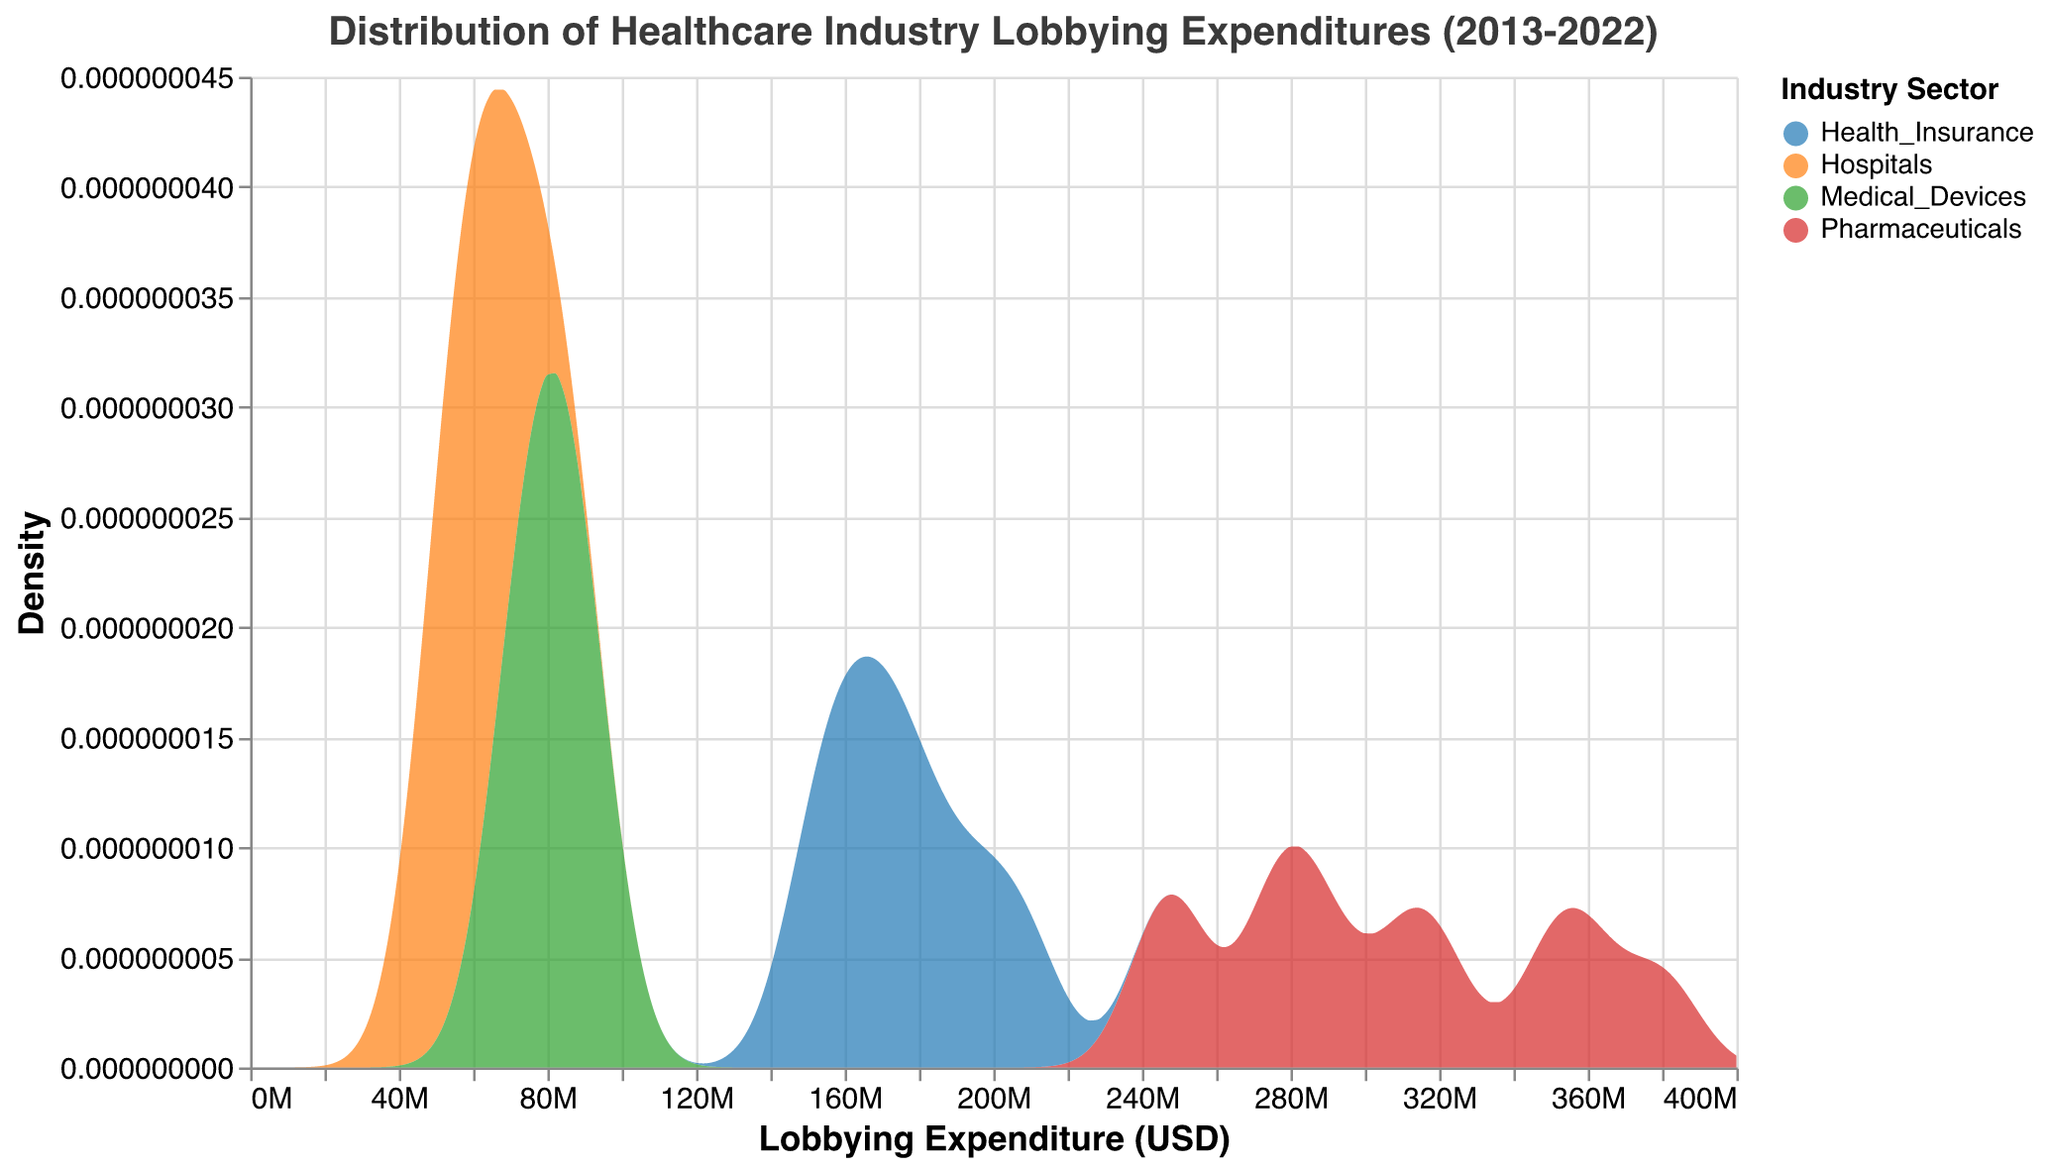What is the title of the plot? The title of the plot is usually found at the top and gives an overview of what the plot is about. Here, it summarizes the content as "Distribution of Healthcare Industry Lobbying Expenditures (2013-2022)"
Answer: Distribution of Healthcare Industry Lobbying Expenditures (2013-2022) What does the x-axis represent? The x-axis is labeled "Lobbying Expenditure (USD)" and indicates the range of lobbying expenditures in US dollars shown on the plot
Answer: Lobbying Expenditure (USD) Which industry sector has the highest peak in density? By examining the density peaks in the plot, the Pharmaceutical industry shows the highest peak, indicating it has the highest expenditure density
Answer: Pharmaceuticals What does the y-axis represent? The y-axis is labeled "Density," indicating the probability density of the lobbying expenditures for different industry sectors
Answer: Density How does the lobbying expenditure for hospitals compare to that of medical devices? To compare, note that the hospitals have a lower density and lower range of lobbying expenditures than medical devices throughout the plot
Answer: Lower Which industry shows the widest spread in lobbying expenditure? The Pharmaceuticals industry shows the widest spread in the density plot, ranging from around $240M to $380M
Answer: Pharmaceuticals What is the range of lobbying expenditures for health insurance companies evident from the density plot? By noting the density spread, health insurance lobbying expenditures range approximately from $150M to $210M
Answer: $150M to $210M Between 2013 and 2022, which industry sector appears to have consistently increased its lobbying expenditure? By observing the density plot trends, the Pharmaceuticals industry shows a consistent rightward shift indicating increasing expenditures over time
Answer: Pharmaceuticals What difference can be observed between the highest and lowest peaks in the density plots? Comparing the densities, the highest peak for Pharmaceuticals implies the most significant expenditure density, whereas hospitals have the lowest peak, showing the least expenditure density
Answer: Pharmaceuticals vs Hospitals When accounting for expenditure density, which two sectors have the closest ranges? Comparing the overlapping densities, health insurance and medical devices sectors show overlapping and closer expenditure ranges
Answer: Health Insurance and Medical Devices 